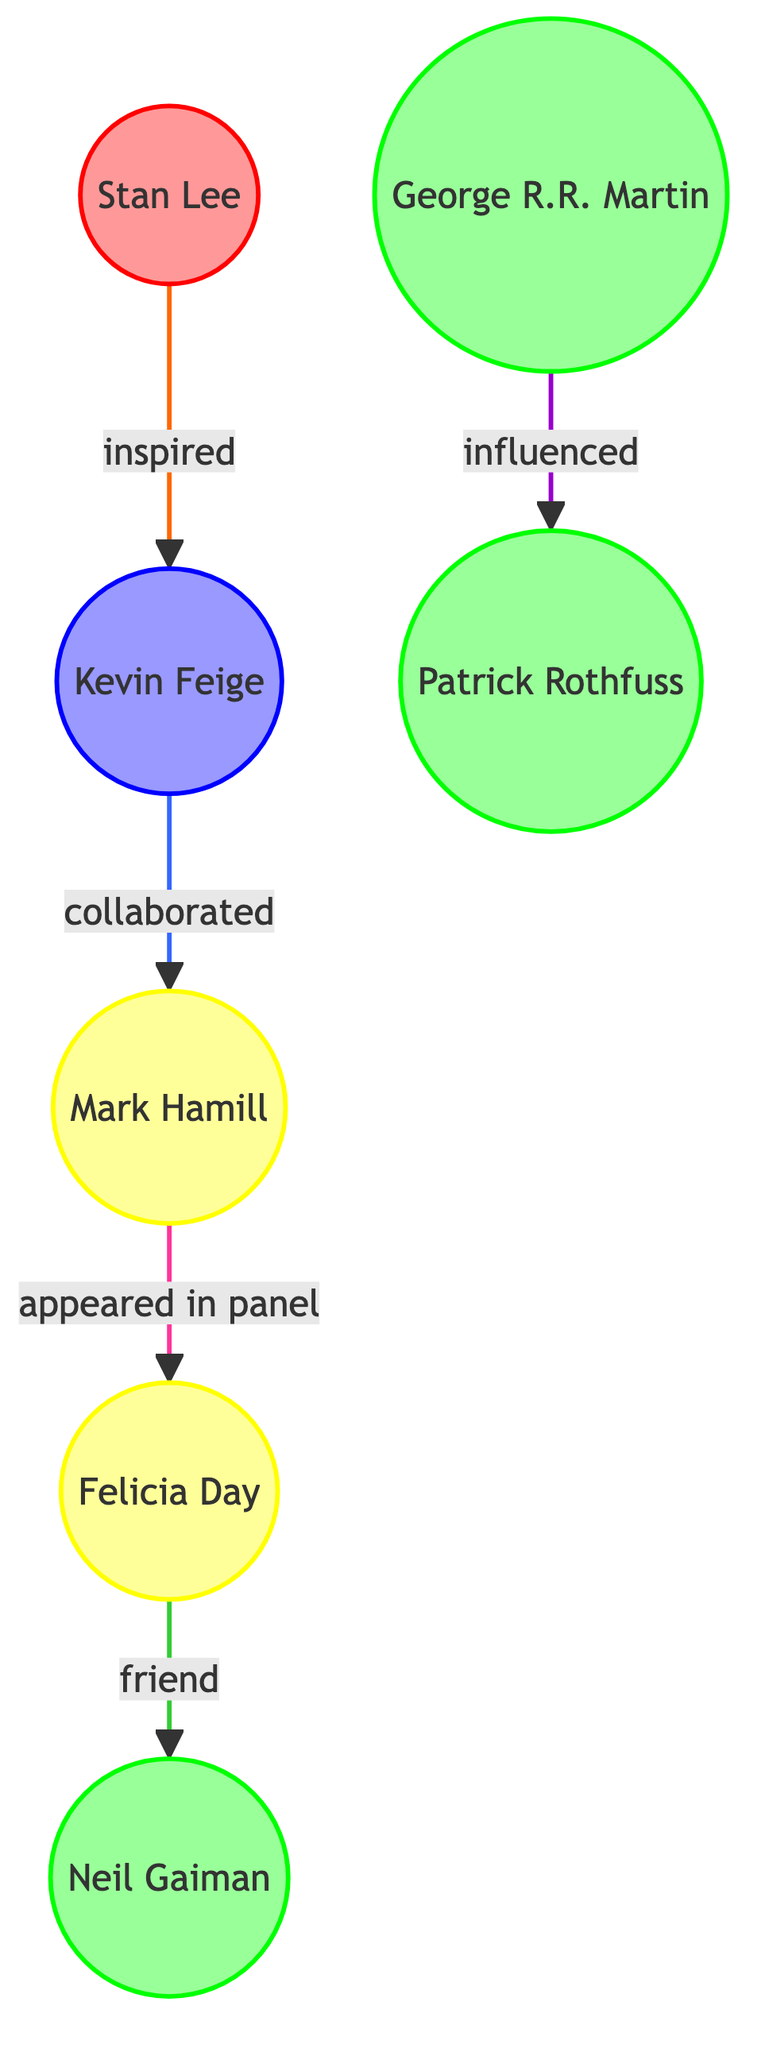What is the total number of nodes in the diagram? Count the entries under "nodes" in the provided data. There are 7 key figures and influencers illustrated within the network.
Answer: 7 Who inspired Kevin Feige? Look at the edge connecting "stan_lee" and "kevin_feige". The relationship labeled "inspired" indicates that Stan Lee is the source of inspiration for Kevin Feige.
Answer: Stan Lee How many edges are in the diagram? Count the entries under "edges" in the data. There are 5 edges representing the relationships between the nodes.
Answer: 5 Which actor appeared in a panel with Felicia Day? Examine the edge that starts from "mark_hamill" and connects to "felicia_day". The relationship is labeled "appeared in panel", indicating Mark Hamill's participation.
Answer: Mark Hamill Which author influenced Patrick Rothfuss? Inspect the relationship that links "george_rr_martin" to "patrick_rothfuss". The edge indicates that George R. R. Martin is the figure who influenced Patrick Rothfuss.
Answer: George R. R. Martin What type of relationship exists between Kevin Feige and Mark Hamill? Refer to the edge that connects "kevin_feige" to "mark_hamill". The relationship is labeled "collaborated", indicating a partnership.
Answer: collaborated Which category does Neil Gaiman belong to? Look at the node labeled "neil_gaiman". It is classified under "author", indicating his primary category in the diagram.
Answer: author Who is friends with Neil Gaiman? Examine the edge that connects "felicia_day" to "neil_gaiman". The relationship is labeled "friend". Therefore, Felicia Day is the person who has a friendship with Neil Gaiman.
Answer: Felicia Day 